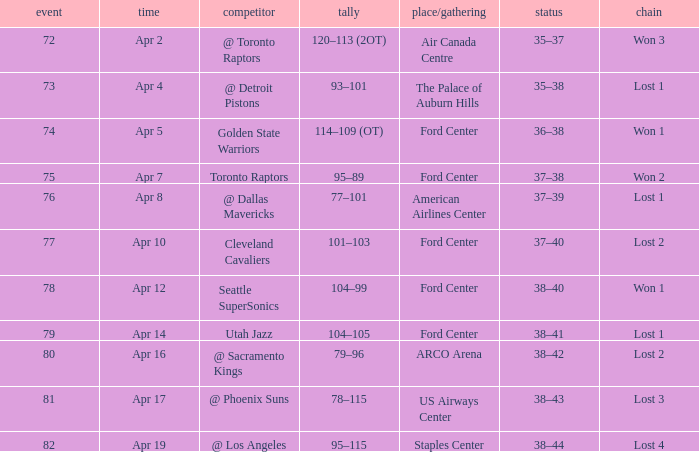What was the location when the opponent was Seattle Supersonics? Ford Center. 